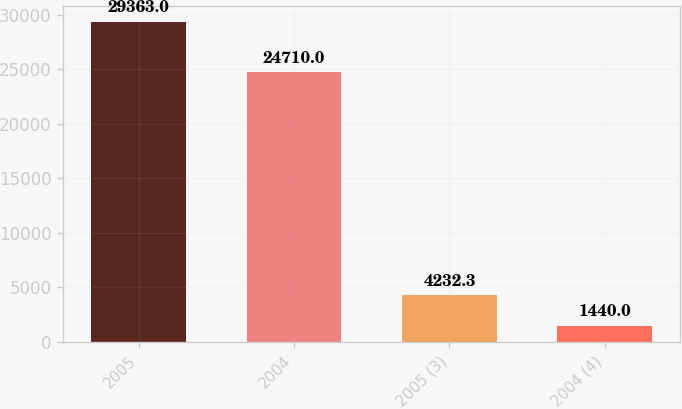<chart> <loc_0><loc_0><loc_500><loc_500><bar_chart><fcel>2005<fcel>2004<fcel>2005 (3)<fcel>2004 (4)<nl><fcel>29363<fcel>24710<fcel>4232.3<fcel>1440<nl></chart> 